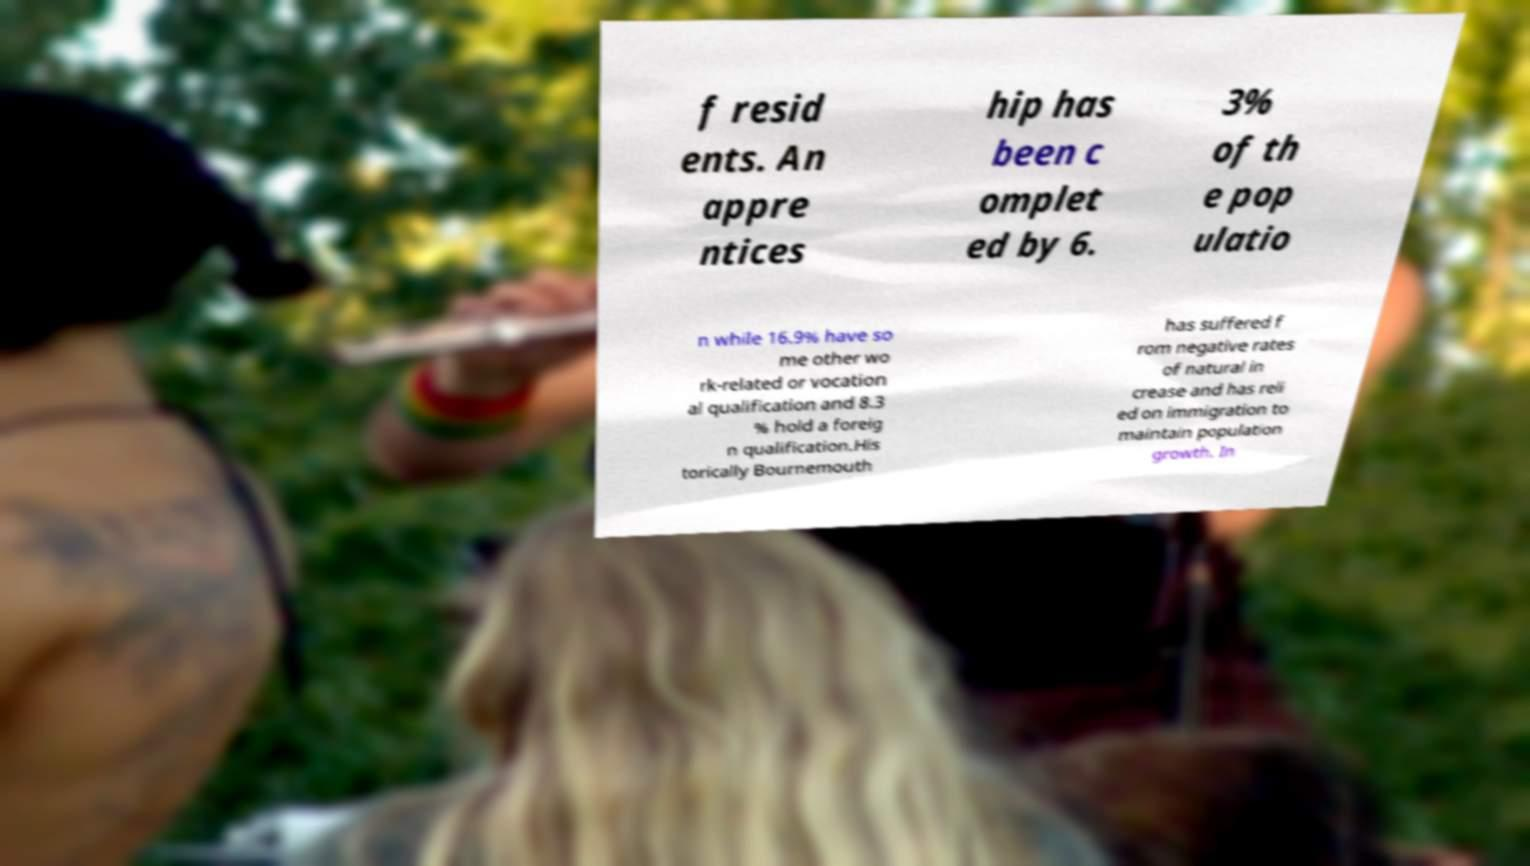I need the written content from this picture converted into text. Can you do that? f resid ents. An appre ntices hip has been c omplet ed by 6. 3% of th e pop ulatio n while 16.9% have so me other wo rk-related or vocation al qualification and 8.3 % hold a foreig n qualification.His torically Bournemouth has suffered f rom negative rates of natural in crease and has reli ed on immigration to maintain population growth. In 